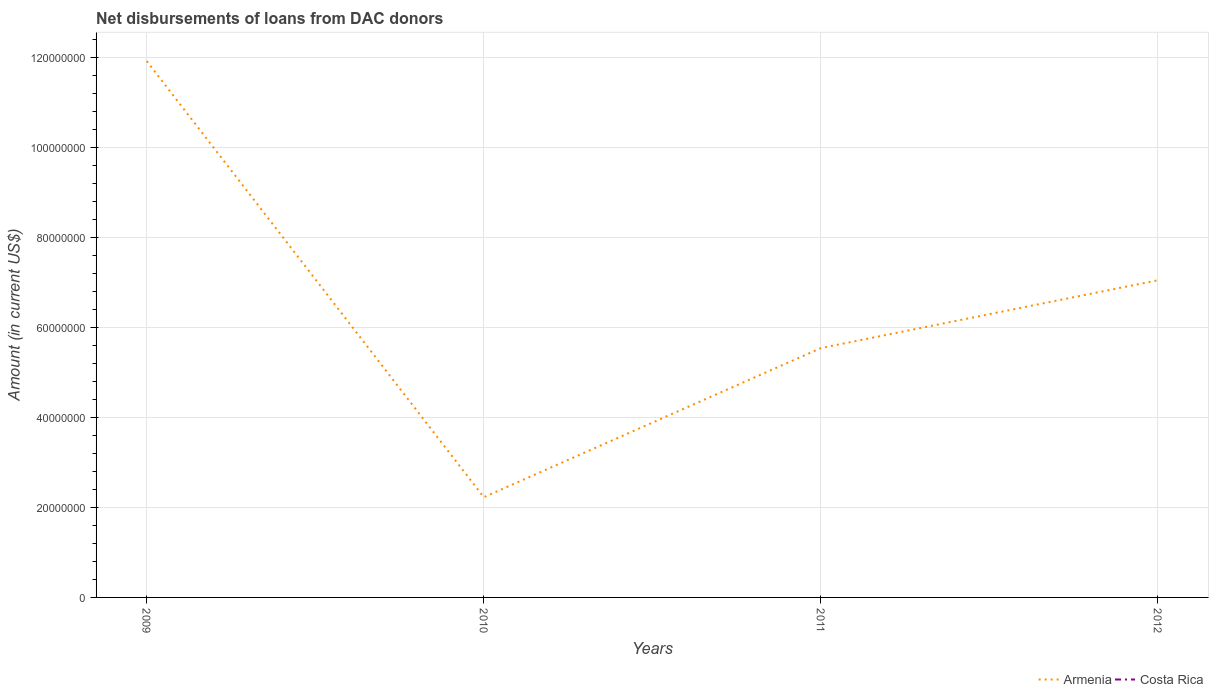How many different coloured lines are there?
Your answer should be compact. 1. Does the line corresponding to Costa Rica intersect with the line corresponding to Armenia?
Ensure brevity in your answer.  No. Across all years, what is the maximum amount of loans disbursed in Costa Rica?
Make the answer very short. 0. What is the total amount of loans disbursed in Armenia in the graph?
Keep it short and to the point. -3.31e+07. What is the difference between the highest and the second highest amount of loans disbursed in Armenia?
Offer a terse response. 9.69e+07. How many lines are there?
Provide a succinct answer. 1. What is the difference between two consecutive major ticks on the Y-axis?
Offer a very short reply. 2.00e+07. Does the graph contain grids?
Your answer should be very brief. Yes. How many legend labels are there?
Ensure brevity in your answer.  2. How are the legend labels stacked?
Provide a short and direct response. Horizontal. What is the title of the graph?
Your answer should be compact. Net disbursements of loans from DAC donors. What is the label or title of the X-axis?
Offer a terse response. Years. What is the Amount (in current US$) of Armenia in 2009?
Offer a terse response. 1.19e+08. What is the Amount (in current US$) of Armenia in 2010?
Your answer should be very brief. 2.23e+07. What is the Amount (in current US$) of Armenia in 2011?
Give a very brief answer. 5.54e+07. What is the Amount (in current US$) of Armenia in 2012?
Give a very brief answer. 7.05e+07. What is the Amount (in current US$) in Costa Rica in 2012?
Offer a terse response. 0. Across all years, what is the maximum Amount (in current US$) in Armenia?
Make the answer very short. 1.19e+08. Across all years, what is the minimum Amount (in current US$) in Armenia?
Your answer should be compact. 2.23e+07. What is the total Amount (in current US$) in Armenia in the graph?
Ensure brevity in your answer.  2.67e+08. What is the difference between the Amount (in current US$) of Armenia in 2009 and that in 2010?
Make the answer very short. 9.69e+07. What is the difference between the Amount (in current US$) of Armenia in 2009 and that in 2011?
Offer a terse response. 6.37e+07. What is the difference between the Amount (in current US$) in Armenia in 2009 and that in 2012?
Keep it short and to the point. 4.87e+07. What is the difference between the Amount (in current US$) in Armenia in 2010 and that in 2011?
Give a very brief answer. -3.31e+07. What is the difference between the Amount (in current US$) of Armenia in 2010 and that in 2012?
Your answer should be very brief. -4.82e+07. What is the difference between the Amount (in current US$) in Armenia in 2011 and that in 2012?
Your answer should be compact. -1.51e+07. What is the average Amount (in current US$) in Armenia per year?
Make the answer very short. 6.68e+07. What is the average Amount (in current US$) of Costa Rica per year?
Provide a succinct answer. 0. What is the ratio of the Amount (in current US$) in Armenia in 2009 to that in 2010?
Give a very brief answer. 5.35. What is the ratio of the Amount (in current US$) of Armenia in 2009 to that in 2011?
Make the answer very short. 2.15. What is the ratio of the Amount (in current US$) of Armenia in 2009 to that in 2012?
Make the answer very short. 1.69. What is the ratio of the Amount (in current US$) in Armenia in 2010 to that in 2011?
Provide a succinct answer. 0.4. What is the ratio of the Amount (in current US$) of Armenia in 2010 to that in 2012?
Ensure brevity in your answer.  0.32. What is the ratio of the Amount (in current US$) in Armenia in 2011 to that in 2012?
Make the answer very short. 0.79. What is the difference between the highest and the second highest Amount (in current US$) of Armenia?
Give a very brief answer. 4.87e+07. What is the difference between the highest and the lowest Amount (in current US$) of Armenia?
Your answer should be very brief. 9.69e+07. 